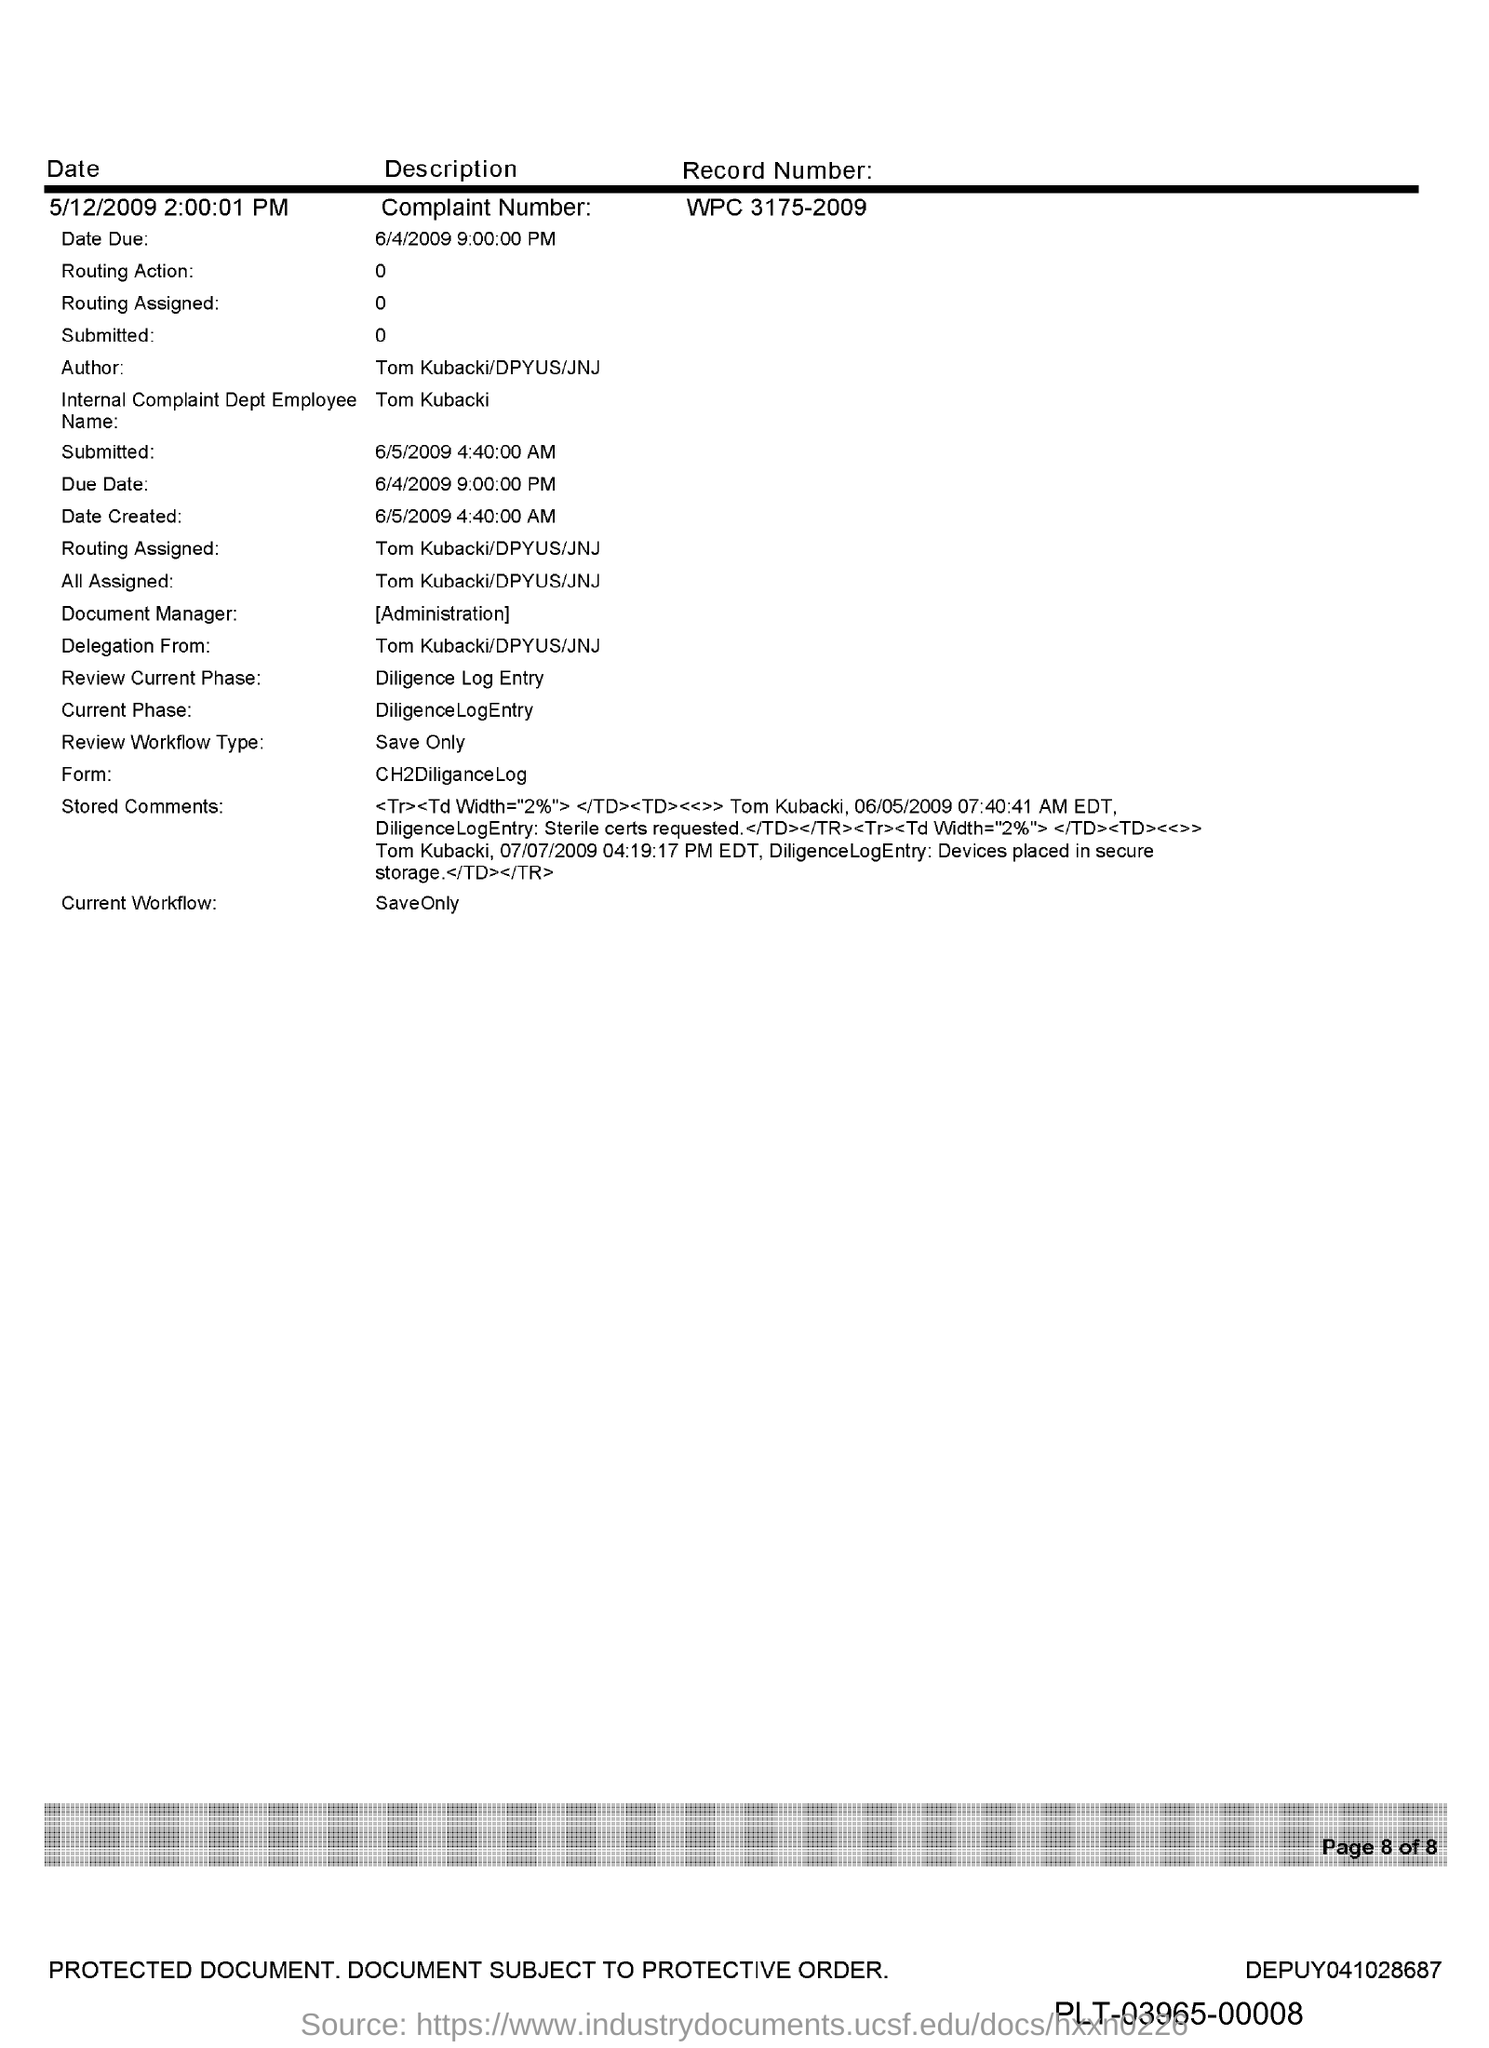What is the Internal Complaint Dept Employee Name mentioned in the document?
Your response must be concise. Tom Kubacki. What is the complaint number given in the document?
Make the answer very short. WPC 3175-2009. What is the submitted date & time mentioned in the document?
Ensure brevity in your answer.  6/5/2009 4:40:00 am. 